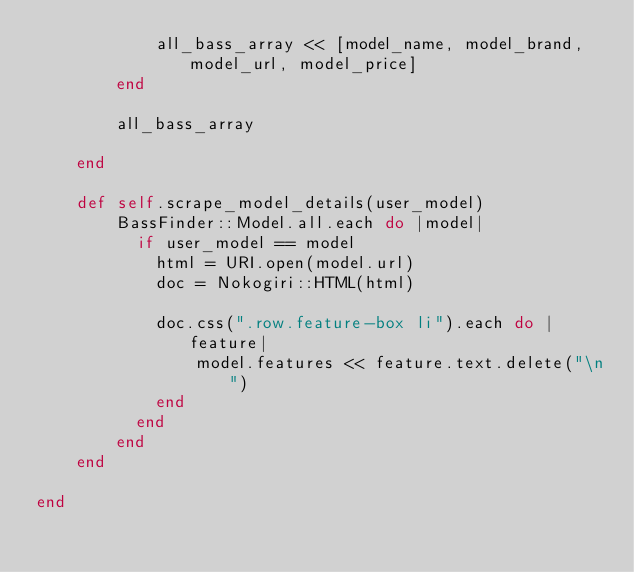Convert code to text. <code><loc_0><loc_0><loc_500><loc_500><_Ruby_>            all_bass_array << [model_name, model_brand, model_url, model_price]
        end   

        all_bass_array
          
    end

    def self.scrape_model_details(user_model)
        BassFinder::Model.all.each do |model|
          if user_model == model 
            html = URI.open(model.url)
            doc = Nokogiri::HTML(html)

            doc.css(".row.feature-box li").each do |feature|
                model.features << feature.text.delete("\n")
            end
          end
        end
    end

end</code> 